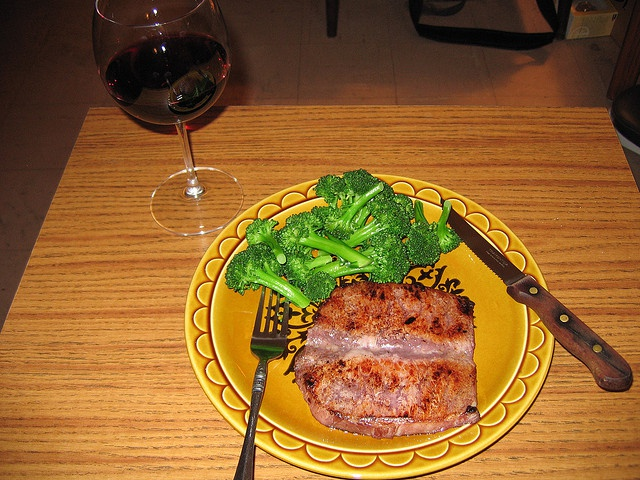Describe the objects in this image and their specific colors. I can see dining table in red, black, and orange tones, wine glass in black, red, maroon, and orange tones, broccoli in black, green, and darkgreen tones, knife in black, maroon, and brown tones, and fork in black, maroon, olive, and orange tones in this image. 